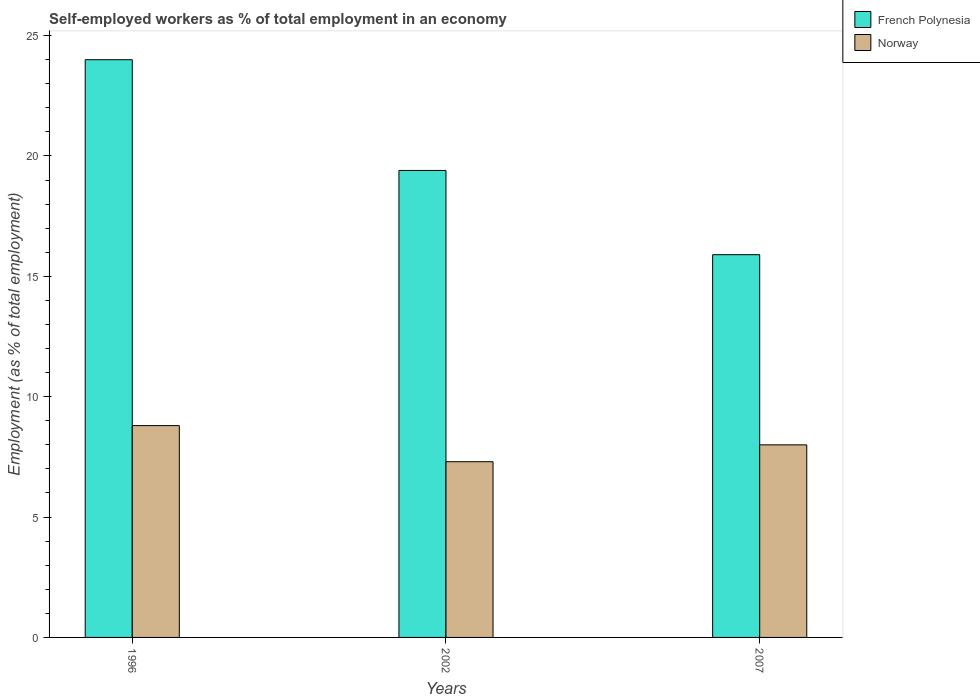How many different coloured bars are there?
Your response must be concise. 2. Are the number of bars per tick equal to the number of legend labels?
Offer a very short reply. Yes. Are the number of bars on each tick of the X-axis equal?
Your response must be concise. Yes. How many bars are there on the 2nd tick from the left?
Keep it short and to the point. 2. What is the label of the 2nd group of bars from the left?
Ensure brevity in your answer.  2002. What is the percentage of self-employed workers in French Polynesia in 2007?
Keep it short and to the point. 15.9. Across all years, what is the maximum percentage of self-employed workers in Norway?
Provide a short and direct response. 8.8. Across all years, what is the minimum percentage of self-employed workers in French Polynesia?
Your answer should be very brief. 15.9. What is the total percentage of self-employed workers in Norway in the graph?
Ensure brevity in your answer.  24.1. What is the difference between the percentage of self-employed workers in Norway in 2002 and that in 2007?
Your answer should be compact. -0.7. What is the difference between the percentage of self-employed workers in French Polynesia in 2007 and the percentage of self-employed workers in Norway in 2002?
Provide a short and direct response. 8.6. What is the average percentage of self-employed workers in Norway per year?
Make the answer very short. 8.03. In the year 2002, what is the difference between the percentage of self-employed workers in Norway and percentage of self-employed workers in French Polynesia?
Ensure brevity in your answer.  -12.1. In how many years, is the percentage of self-employed workers in French Polynesia greater than 20 %?
Your answer should be very brief. 1. What is the ratio of the percentage of self-employed workers in Norway in 1996 to that in 2007?
Offer a terse response. 1.1. What is the difference between the highest and the second highest percentage of self-employed workers in French Polynesia?
Offer a terse response. 4.6. What is the difference between the highest and the lowest percentage of self-employed workers in Norway?
Make the answer very short. 1.5. How many bars are there?
Your answer should be compact. 6. What is the difference between two consecutive major ticks on the Y-axis?
Ensure brevity in your answer.  5. Does the graph contain any zero values?
Provide a short and direct response. No. Does the graph contain grids?
Your response must be concise. No. How many legend labels are there?
Your response must be concise. 2. How are the legend labels stacked?
Ensure brevity in your answer.  Vertical. What is the title of the graph?
Provide a succinct answer. Self-employed workers as % of total employment in an economy. What is the label or title of the Y-axis?
Keep it short and to the point. Employment (as % of total employment). What is the Employment (as % of total employment) in Norway in 1996?
Your answer should be very brief. 8.8. What is the Employment (as % of total employment) in French Polynesia in 2002?
Keep it short and to the point. 19.4. What is the Employment (as % of total employment) in Norway in 2002?
Offer a very short reply. 7.3. What is the Employment (as % of total employment) of French Polynesia in 2007?
Your response must be concise. 15.9. What is the Employment (as % of total employment) of Norway in 2007?
Keep it short and to the point. 8. Across all years, what is the maximum Employment (as % of total employment) of French Polynesia?
Offer a very short reply. 24. Across all years, what is the maximum Employment (as % of total employment) in Norway?
Ensure brevity in your answer.  8.8. Across all years, what is the minimum Employment (as % of total employment) of French Polynesia?
Offer a very short reply. 15.9. Across all years, what is the minimum Employment (as % of total employment) in Norway?
Ensure brevity in your answer.  7.3. What is the total Employment (as % of total employment) in French Polynesia in the graph?
Offer a terse response. 59.3. What is the total Employment (as % of total employment) of Norway in the graph?
Provide a succinct answer. 24.1. What is the difference between the Employment (as % of total employment) in French Polynesia in 1996 and that in 2002?
Provide a succinct answer. 4.6. What is the difference between the Employment (as % of total employment) in Norway in 1996 and that in 2002?
Make the answer very short. 1.5. What is the difference between the Employment (as % of total employment) in French Polynesia in 1996 and the Employment (as % of total employment) in Norway in 2002?
Ensure brevity in your answer.  16.7. What is the average Employment (as % of total employment) of French Polynesia per year?
Provide a succinct answer. 19.77. What is the average Employment (as % of total employment) of Norway per year?
Offer a terse response. 8.03. In the year 2007, what is the difference between the Employment (as % of total employment) of French Polynesia and Employment (as % of total employment) of Norway?
Give a very brief answer. 7.9. What is the ratio of the Employment (as % of total employment) in French Polynesia in 1996 to that in 2002?
Provide a succinct answer. 1.24. What is the ratio of the Employment (as % of total employment) of Norway in 1996 to that in 2002?
Offer a terse response. 1.21. What is the ratio of the Employment (as % of total employment) in French Polynesia in 1996 to that in 2007?
Your answer should be compact. 1.51. What is the ratio of the Employment (as % of total employment) in Norway in 1996 to that in 2007?
Your answer should be very brief. 1.1. What is the ratio of the Employment (as % of total employment) in French Polynesia in 2002 to that in 2007?
Give a very brief answer. 1.22. What is the ratio of the Employment (as % of total employment) of Norway in 2002 to that in 2007?
Offer a terse response. 0.91. What is the difference between the highest and the second highest Employment (as % of total employment) of French Polynesia?
Give a very brief answer. 4.6. What is the difference between the highest and the second highest Employment (as % of total employment) of Norway?
Your answer should be compact. 0.8. What is the difference between the highest and the lowest Employment (as % of total employment) of French Polynesia?
Offer a very short reply. 8.1. 